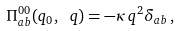<formula> <loc_0><loc_0><loc_500><loc_500>\Pi ^ { 0 0 } _ { a b } ( q _ { 0 } , \ q ) = - \kappa \, q ^ { 2 } \delta _ { a b } \, ,</formula> 